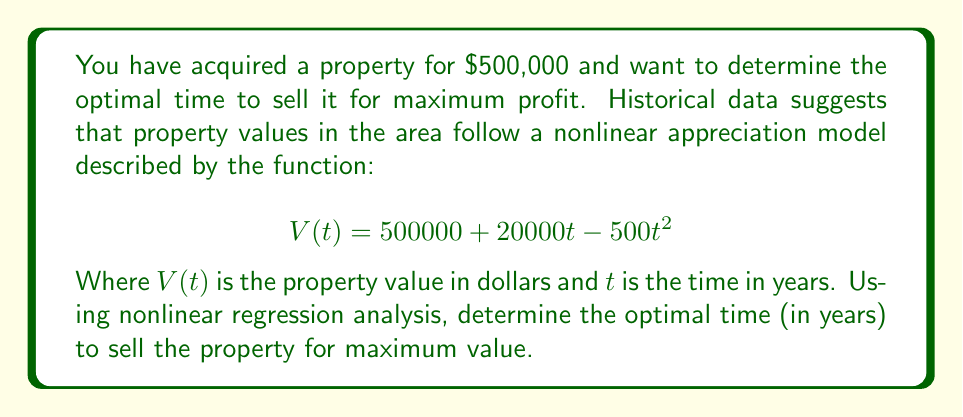Can you solve this math problem? To find the optimal time for maximum property value, we need to find the maximum of the function $V(t)$. This can be done by following these steps:

1. Find the derivative of $V(t)$ with respect to $t$:
   $$V'(t) = 20000 - 1000t$$

2. Set the derivative equal to zero and solve for $t$:
   $$20000 - 1000t = 0$$
   $$-1000t = -20000$$
   $$t = 20$$

3. To confirm this is a maximum (not a minimum), check the second derivative:
   $$V''(t) = -1000$$
   Since $V''(t)$ is negative, we confirm that $t = 20$ gives a maximum.

4. Calculate the maximum value:
   $$V(20) = 500000 + 20000(20) - 500(20)^2$$
   $$= 500000 + 400000 - 200000$$
   $$= 700000$$

Therefore, the optimal time to sell the property is 20 years after acquisition, at which point its value will be $700,000.
Answer: 20 years 